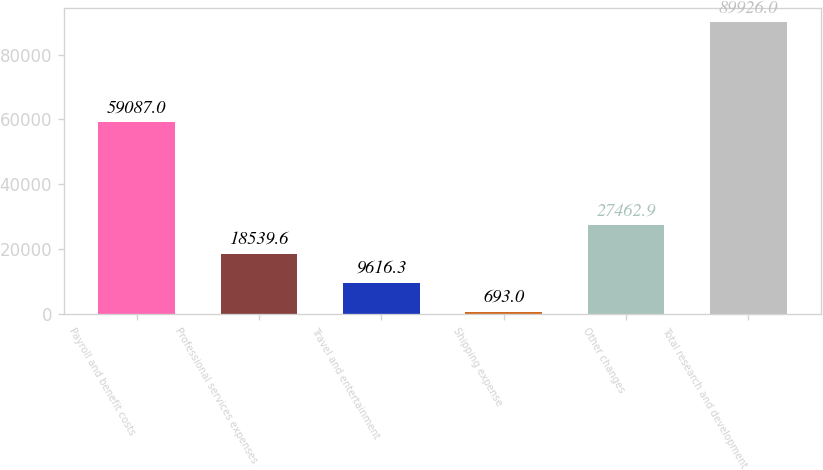Convert chart to OTSL. <chart><loc_0><loc_0><loc_500><loc_500><bar_chart><fcel>Payroll and benefit costs<fcel>Professional services expenses<fcel>Travel and entertainment<fcel>Shipping expense<fcel>Other changes<fcel>Total research and development<nl><fcel>59087<fcel>18539.6<fcel>9616.3<fcel>693<fcel>27462.9<fcel>89926<nl></chart> 